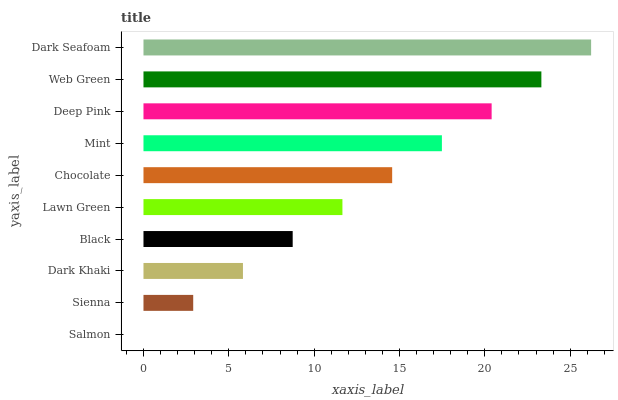Is Salmon the minimum?
Answer yes or no. Yes. Is Dark Seafoam the maximum?
Answer yes or no. Yes. Is Sienna the minimum?
Answer yes or no. No. Is Sienna the maximum?
Answer yes or no. No. Is Sienna greater than Salmon?
Answer yes or no. Yes. Is Salmon less than Sienna?
Answer yes or no. Yes. Is Salmon greater than Sienna?
Answer yes or no. No. Is Sienna less than Salmon?
Answer yes or no. No. Is Chocolate the high median?
Answer yes or no. Yes. Is Lawn Green the low median?
Answer yes or no. Yes. Is Deep Pink the high median?
Answer yes or no. No. Is Deep Pink the low median?
Answer yes or no. No. 